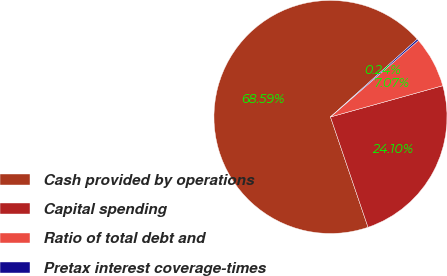Convert chart to OTSL. <chart><loc_0><loc_0><loc_500><loc_500><pie_chart><fcel>Cash provided by operations<fcel>Capital spending<fcel>Ratio of total debt and<fcel>Pretax interest coverage-times<nl><fcel>68.59%<fcel>24.1%<fcel>7.07%<fcel>0.24%<nl></chart> 